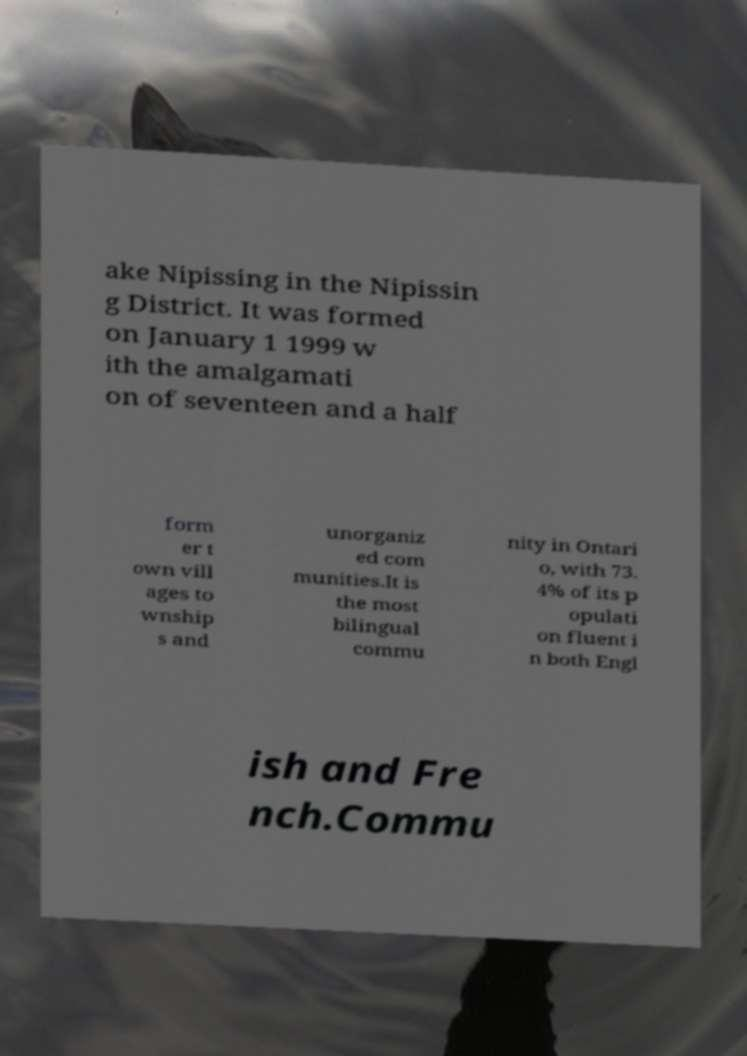Could you extract and type out the text from this image? ake Nipissing in the Nipissin g District. It was formed on January 1 1999 w ith the amalgamati on of seventeen and a half form er t own vill ages to wnship s and unorganiz ed com munities.It is the most bilingual commu nity in Ontari o, with 73. 4% of its p opulati on fluent i n both Engl ish and Fre nch.Commu 